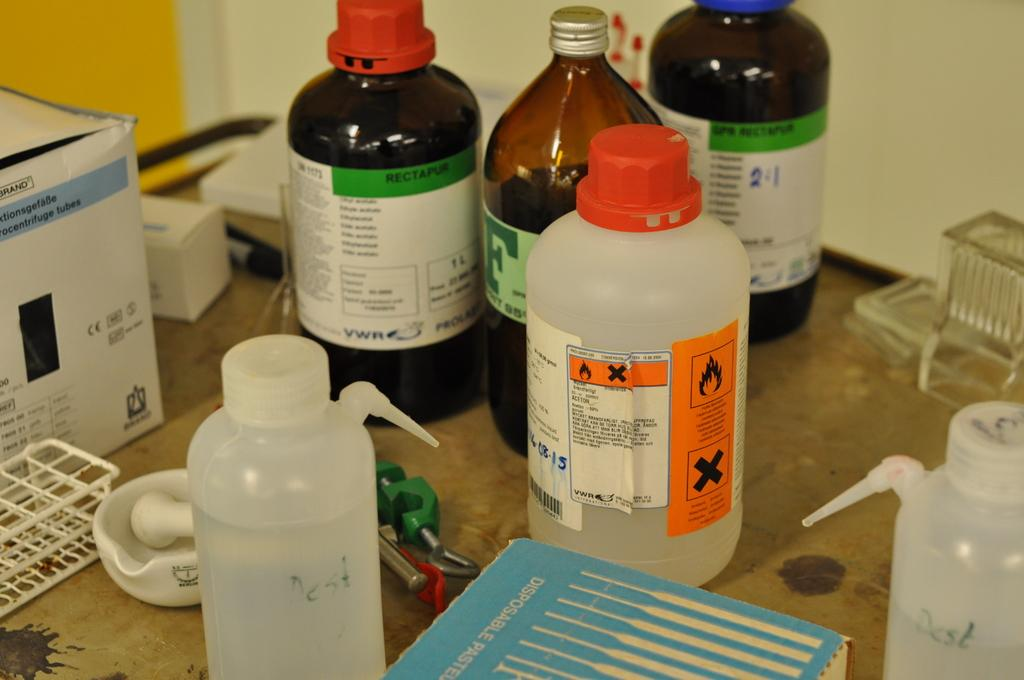Provide a one-sentence caption for the provided image. Bottle with a green label that says "Rectapur" near the top. 